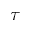<formula> <loc_0><loc_0><loc_500><loc_500>\tau</formula> 